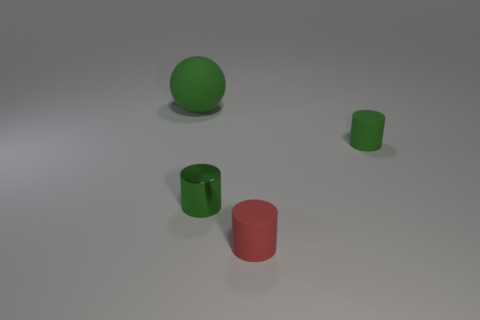Is there anything else that has the same size as the rubber ball?
Make the answer very short. No. What is the green thing that is behind the tiny green rubber cylinder made of?
Your answer should be very brief. Rubber. What is the size of the matte cylinder that is the same color as the tiny metal object?
Your answer should be compact. Small. Is there a green rubber object that has the same size as the green shiny thing?
Provide a short and direct response. Yes. Does the small green rubber thing have the same shape as the tiny rubber thing in front of the tiny green rubber cylinder?
Your answer should be very brief. Yes. Do the thing on the left side of the tiny shiny thing and the green matte object that is in front of the large thing have the same size?
Provide a succinct answer. No. How many other objects are the same shape as the red object?
Your response must be concise. 2. The large green sphere that is to the left of the green matte object in front of the green sphere is made of what material?
Ensure brevity in your answer.  Rubber. What number of rubber objects are either spheres or big cyan blocks?
Offer a terse response. 1. There is a rubber thing that is to the left of the tiny red cylinder; is there a green object in front of it?
Offer a terse response. Yes. 